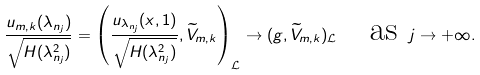Convert formula to latex. <formula><loc_0><loc_0><loc_500><loc_500>\frac { u _ { m , k } ( \lambda _ { n _ { j } } ) } { \sqrt { H ( \lambda _ { n _ { j } } ^ { 2 } ) } } = \left ( \frac { u _ { \lambda _ { n _ { j } } } ( x , 1 ) } { \sqrt { H ( \lambda _ { n _ { j } } ^ { 2 } ) } } , \widetilde { V } _ { m , k } \right ) _ { \mathcal { L } } \to ( g , \widetilde { V } _ { m , k } ) _ { \mathcal { L } } \quad \text {as } j \to + \infty .</formula> 